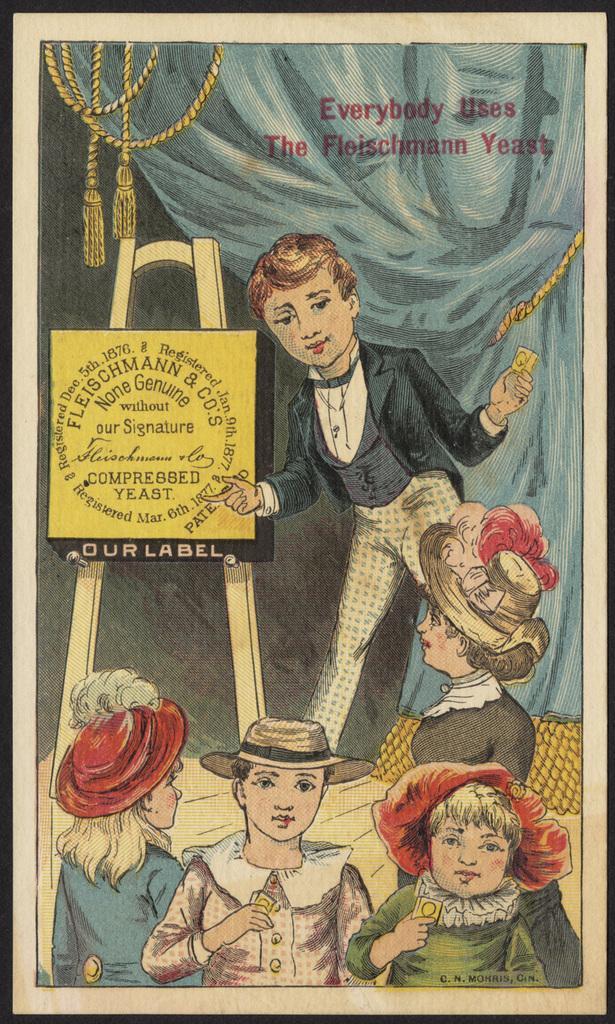Can you describe this image briefly? This image is a depiction. In this image we can see the frame of the people, board, ropes and also the text. 